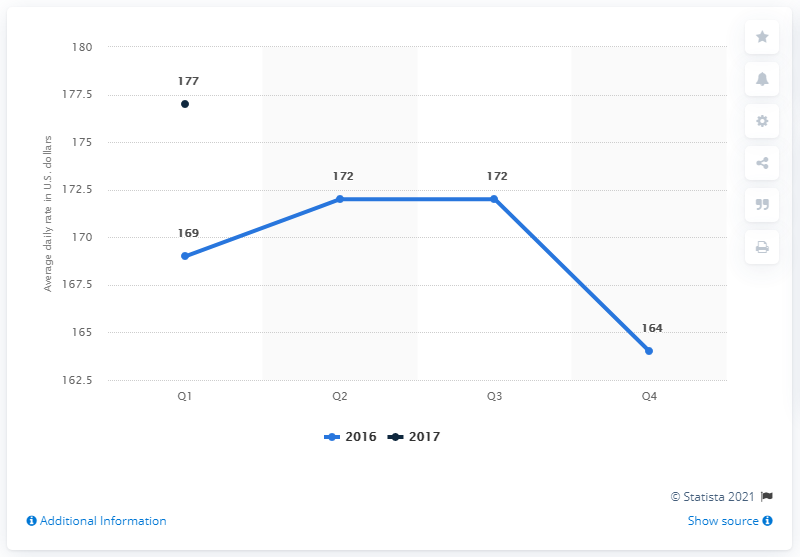Indicate a few pertinent items in this graphic. In the first quarter of 2017, the average daily rate of hotels in San Diego, United States was 177.. As of 2016, the highest daily rate was 172. The difference between the highest value of daily rate in 2017 and 2016 is 5%. 